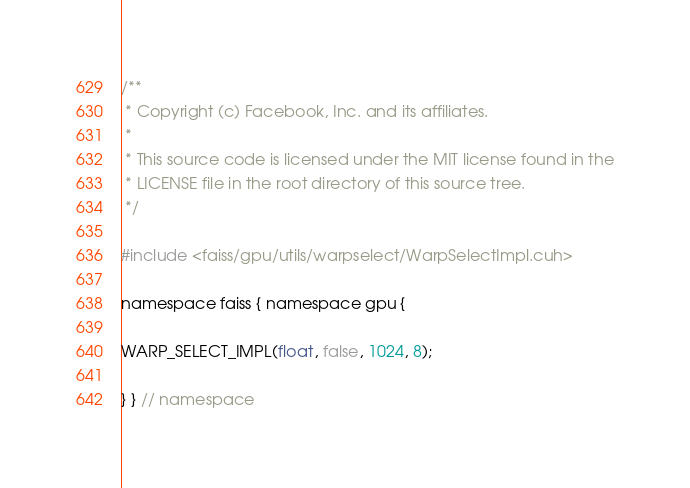Convert code to text. <code><loc_0><loc_0><loc_500><loc_500><_Cuda_>/**
 * Copyright (c) Facebook, Inc. and its affiliates.
 *
 * This source code is licensed under the MIT license found in the
 * LICENSE file in the root directory of this source tree.
 */

#include <faiss/gpu/utils/warpselect/WarpSelectImpl.cuh>

namespace faiss { namespace gpu {

WARP_SELECT_IMPL(float, false, 1024, 8);

} } // namespace
</code> 